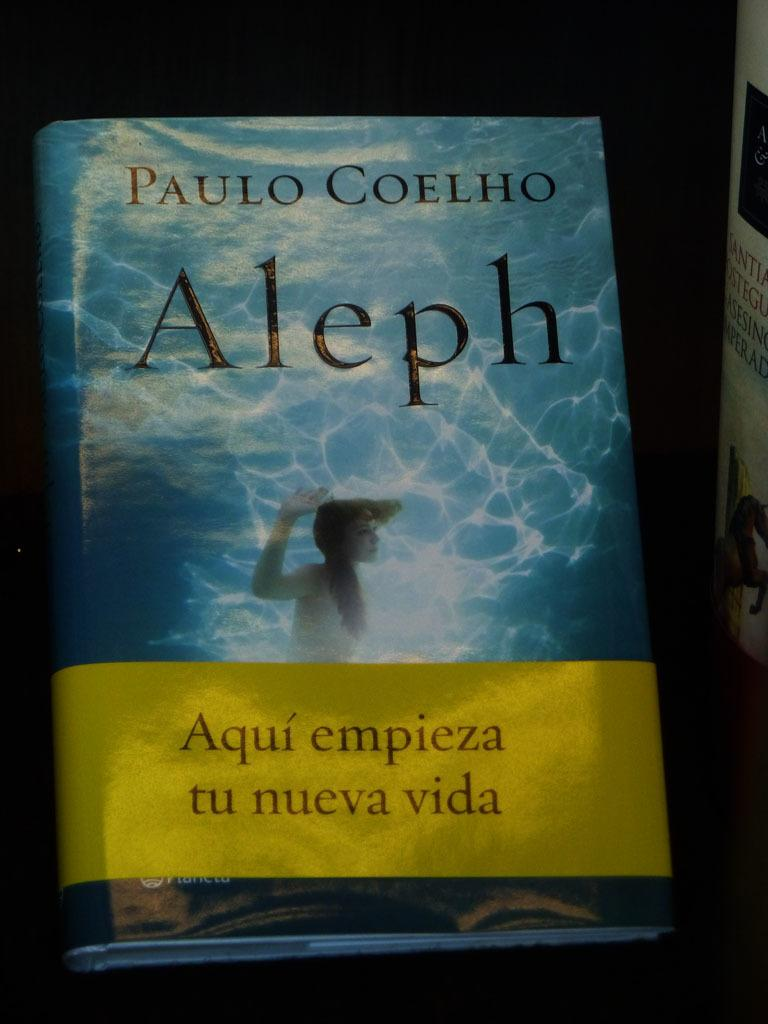<image>
Write a terse but informative summary of the picture. a book written in spanish with a cover of underwater 